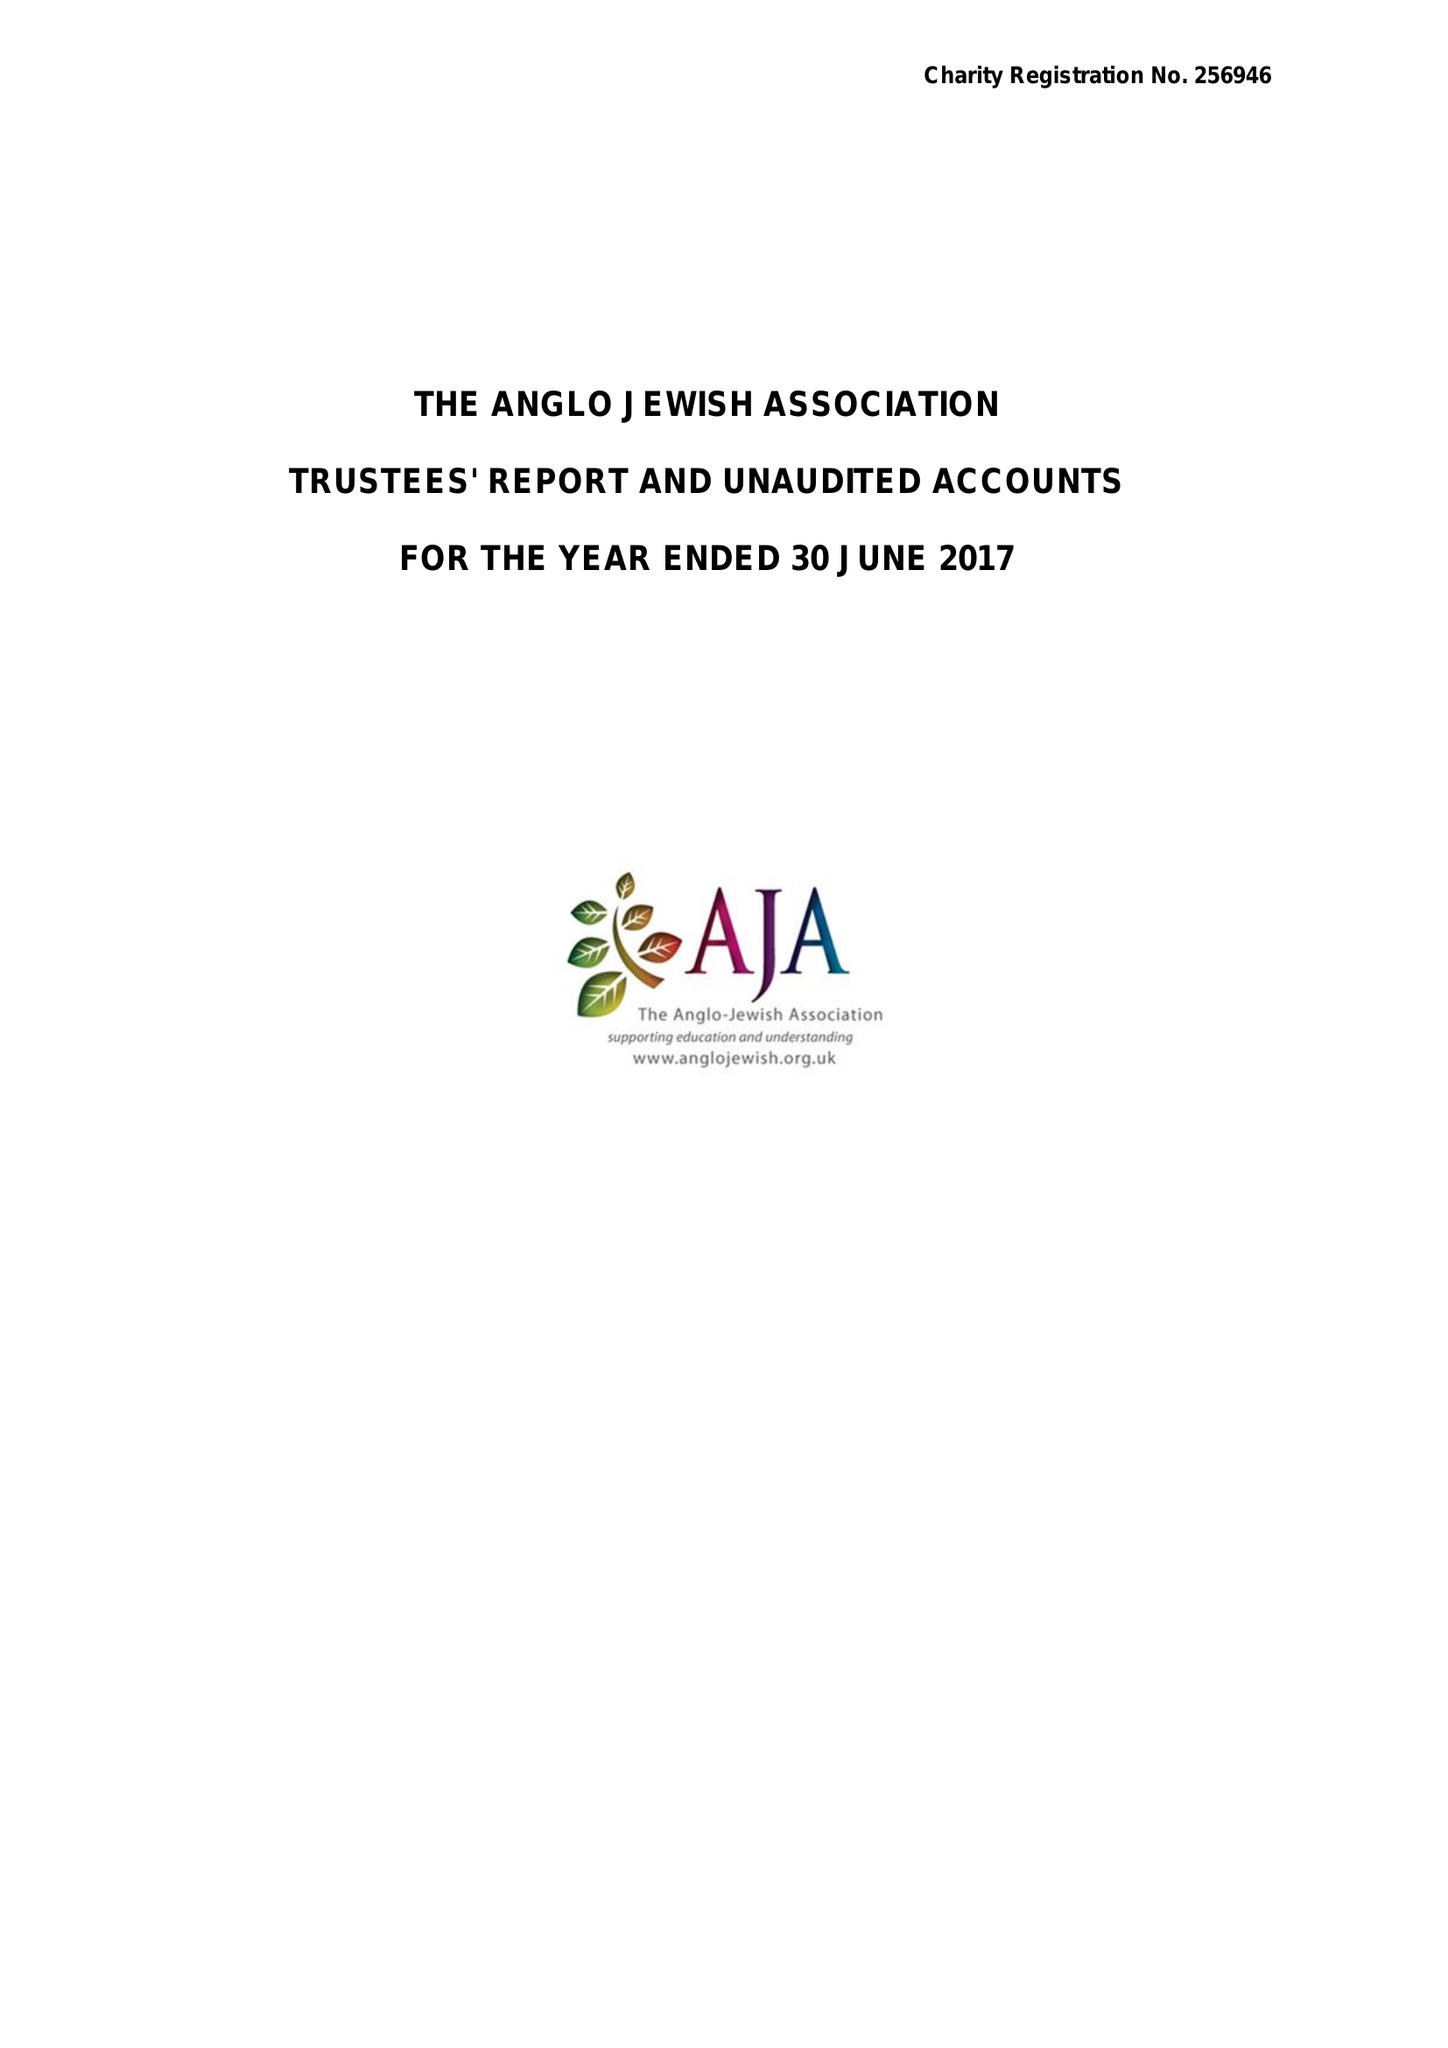What is the value for the charity_name?
Answer the question using a single word or phrase. The Anglo Jewish Association 